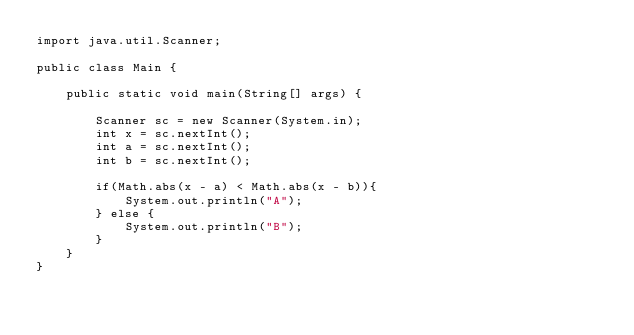<code> <loc_0><loc_0><loc_500><loc_500><_Java_>import java.util.Scanner;

public class Main {

    public static void main(String[] args) {

        Scanner sc = new Scanner(System.in);
        int x = sc.nextInt();
        int a = sc.nextInt();
        int b = sc.nextInt();

        if(Math.abs(x - a) < Math.abs(x - b)){
            System.out.println("A");
        } else {
            System.out.println("B");
        }
    }
}</code> 